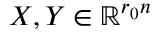<formula> <loc_0><loc_0><loc_500><loc_500>X , Y \in \mathbb { R } ^ { r _ { 0 } n }</formula> 